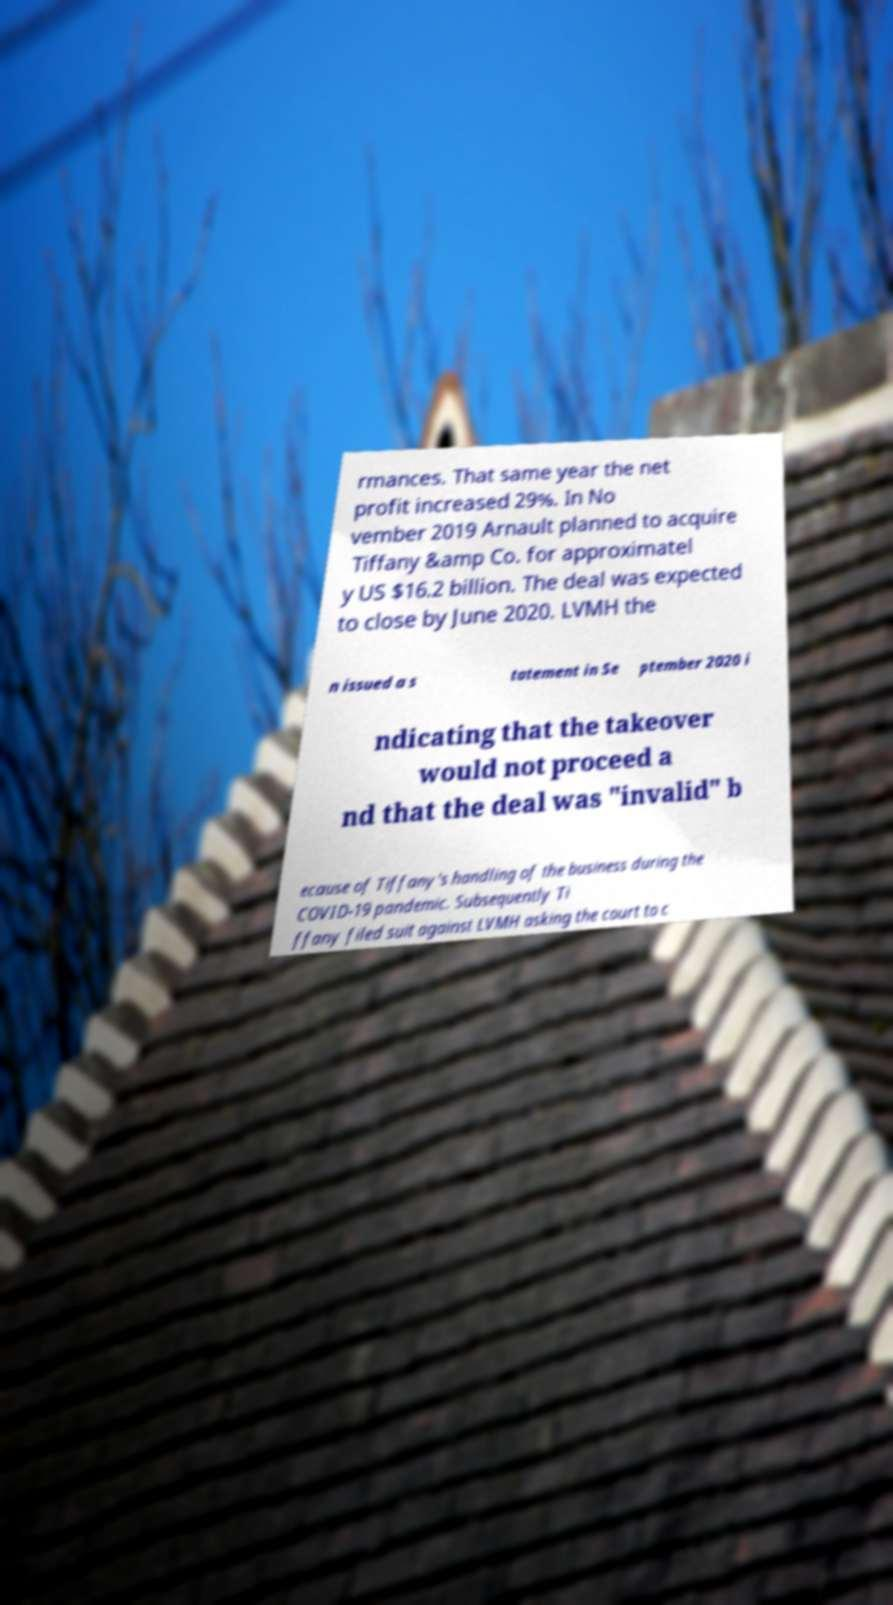Could you assist in decoding the text presented in this image and type it out clearly? rmances. That same year the net profit increased 29%. In No vember 2019 Arnault planned to acquire Tiffany &amp Co. for approximatel y US $16.2 billion. The deal was expected to close by June 2020. LVMH the n issued a s tatement in Se ptember 2020 i ndicating that the takeover would not proceed a nd that the deal was "invalid" b ecause of Tiffany's handling of the business during the COVID-19 pandemic. Subsequently Ti ffany filed suit against LVMH asking the court to c 